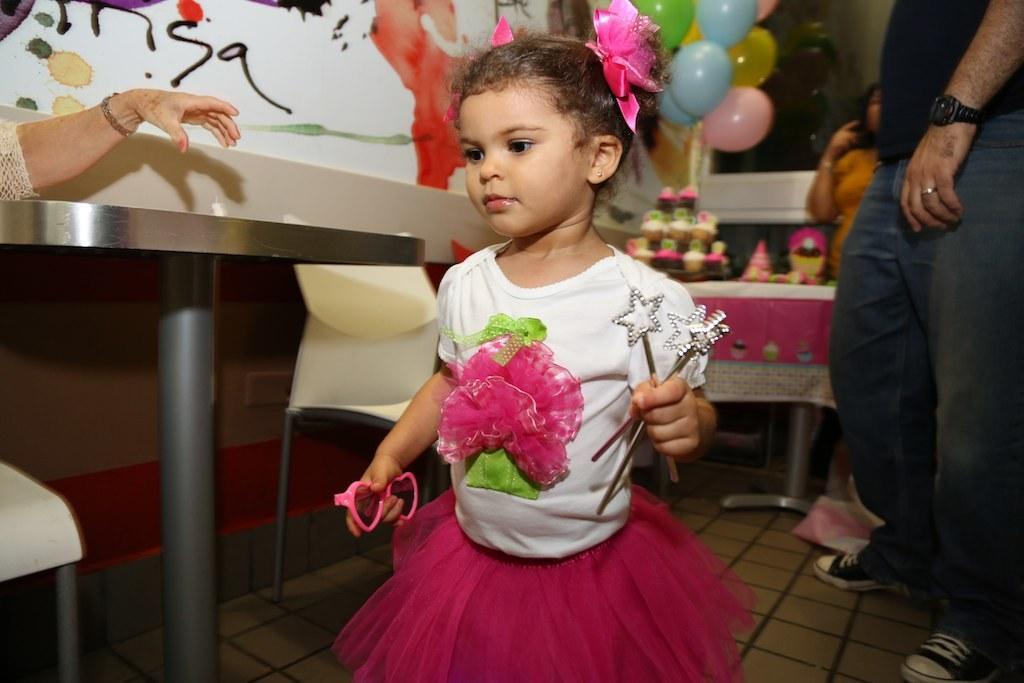How would you summarize this image in a sentence or two? In the image we can see a girl standing, wearing clothes and ear studs and she is holding objects in her hand. Around her there are other people standing and wearing clothes. Here we can see balloons, cake and the table. Here we can see the floor and there are chairs. 